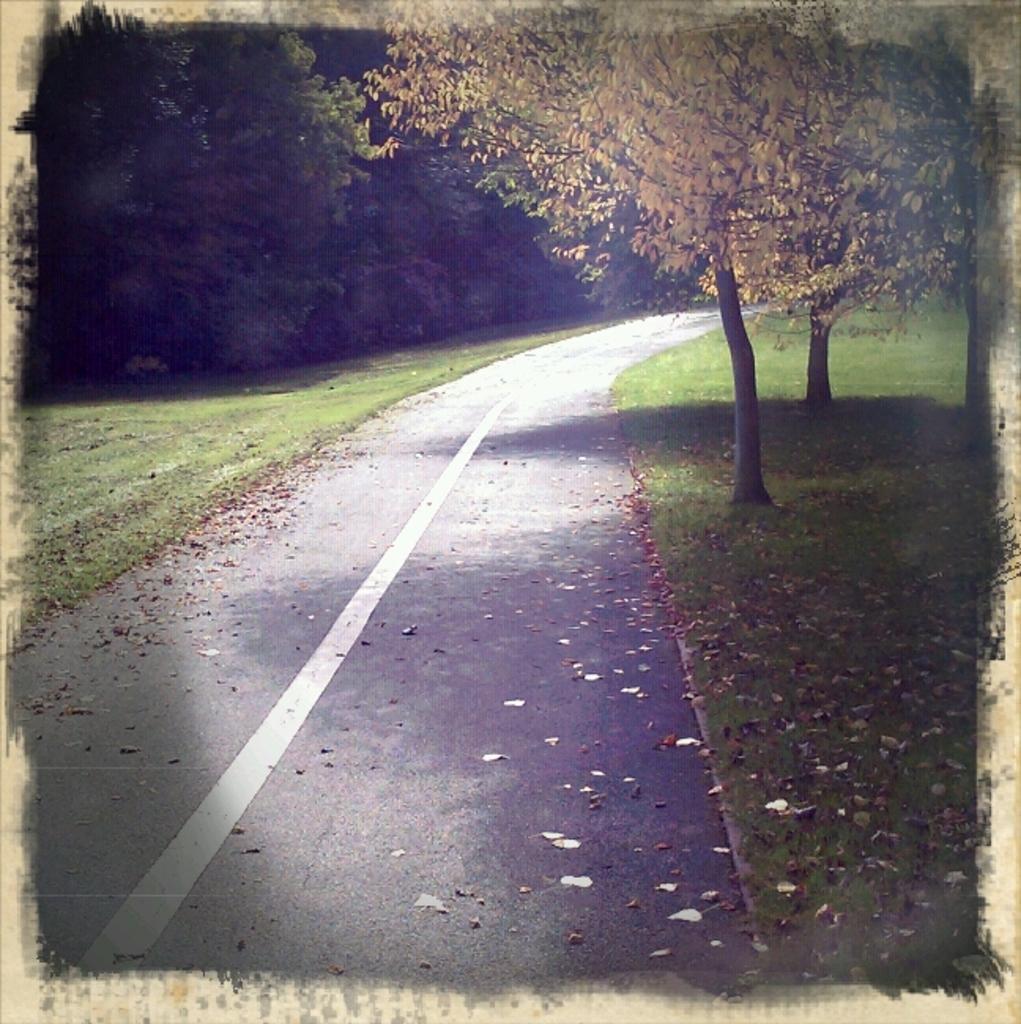How would you summarize this image in a sentence or two? In this picture we can see a road and on the path there are some dry leaves. On the left and right side of the road there are trees. 